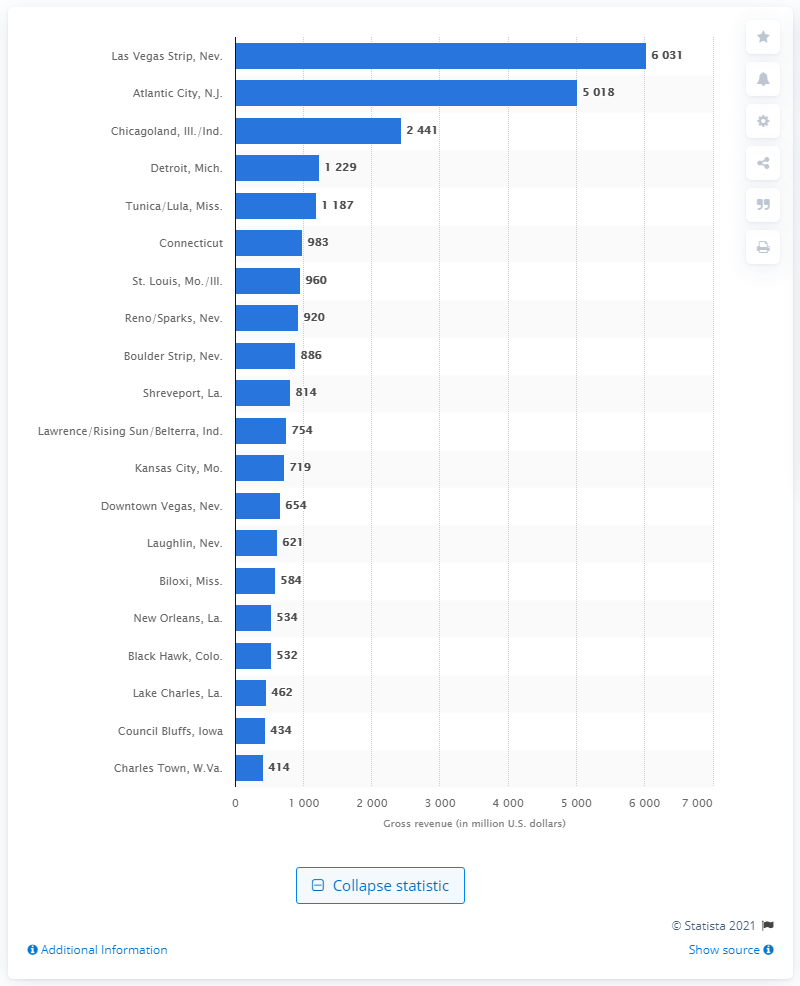Draw attention to some important aspects in this diagram. In 2005, Detroit's gross gaming revenues were 1,229. 